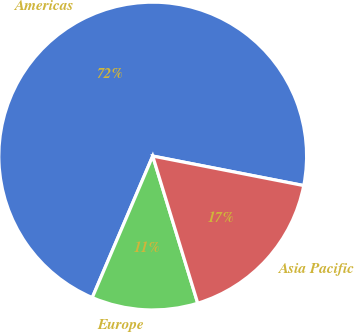Convert chart. <chart><loc_0><loc_0><loc_500><loc_500><pie_chart><fcel>Americas<fcel>Europe<fcel>Asia Pacific<nl><fcel>71.64%<fcel>11.15%<fcel>17.2%<nl></chart> 